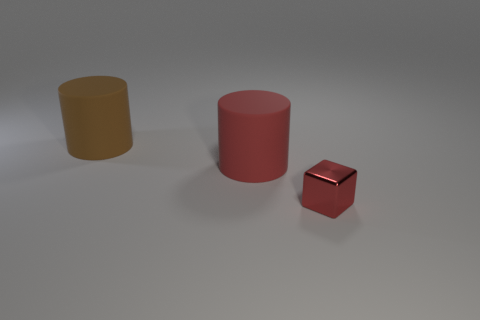Are there any other things that are made of the same material as the tiny red thing?
Keep it short and to the point. No. There is a matte thing that is the same size as the brown cylinder; what color is it?
Provide a short and direct response. Red. How many red matte objects are the same shape as the large brown object?
Your response must be concise. 1. What color is the large rubber cylinder that is in front of the brown cylinder?
Your answer should be compact. Red. What number of metallic objects are brown cylinders or big red cylinders?
Your answer should be very brief. 0. There is a object that is the same color as the block; what is its shape?
Give a very brief answer. Cylinder. What number of other red cylinders are the same size as the red rubber cylinder?
Provide a succinct answer. 0. What is the color of the thing that is on the right side of the big brown matte thing and behind the small red shiny object?
Offer a very short reply. Red. How many objects are either large yellow matte spheres or small red shiny things?
Provide a short and direct response. 1. What number of large things are either blue rubber objects or metal cubes?
Offer a very short reply. 0. 